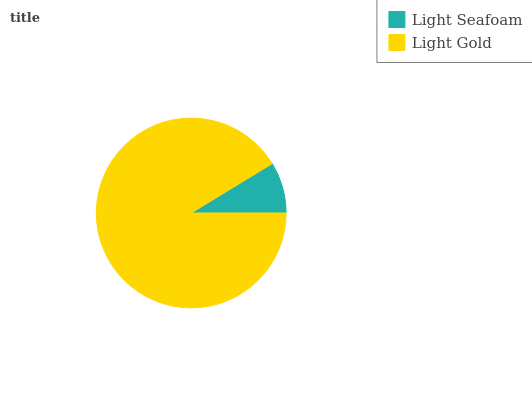Is Light Seafoam the minimum?
Answer yes or no. Yes. Is Light Gold the maximum?
Answer yes or no. Yes. Is Light Gold the minimum?
Answer yes or no. No. Is Light Gold greater than Light Seafoam?
Answer yes or no. Yes. Is Light Seafoam less than Light Gold?
Answer yes or no. Yes. Is Light Seafoam greater than Light Gold?
Answer yes or no. No. Is Light Gold less than Light Seafoam?
Answer yes or no. No. Is Light Gold the high median?
Answer yes or no. Yes. Is Light Seafoam the low median?
Answer yes or no. Yes. Is Light Seafoam the high median?
Answer yes or no. No. Is Light Gold the low median?
Answer yes or no. No. 